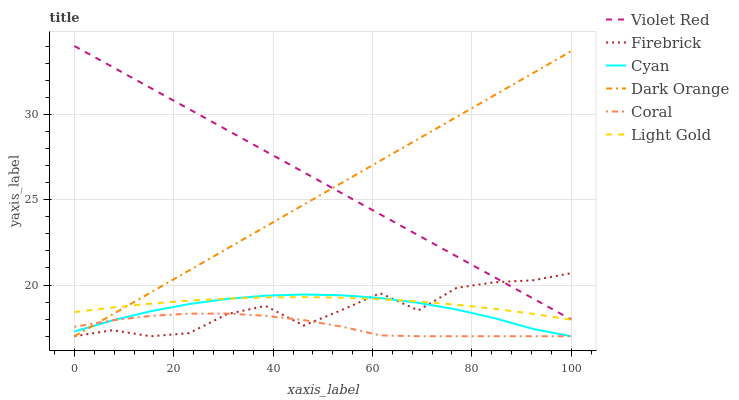Does Coral have the minimum area under the curve?
Answer yes or no. Yes. Does Violet Red have the maximum area under the curve?
Answer yes or no. Yes. Does Violet Red have the minimum area under the curve?
Answer yes or no. No. Does Coral have the maximum area under the curve?
Answer yes or no. No. Is Violet Red the smoothest?
Answer yes or no. Yes. Is Firebrick the roughest?
Answer yes or no. Yes. Is Coral the smoothest?
Answer yes or no. No. Is Coral the roughest?
Answer yes or no. No. Does Dark Orange have the lowest value?
Answer yes or no. Yes. Does Violet Red have the lowest value?
Answer yes or no. No. Does Violet Red have the highest value?
Answer yes or no. Yes. Does Coral have the highest value?
Answer yes or no. No. Is Light Gold less than Violet Red?
Answer yes or no. Yes. Is Light Gold greater than Coral?
Answer yes or no. Yes. Does Cyan intersect Coral?
Answer yes or no. Yes. Is Cyan less than Coral?
Answer yes or no. No. Is Cyan greater than Coral?
Answer yes or no. No. Does Light Gold intersect Violet Red?
Answer yes or no. No. 